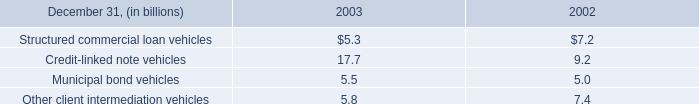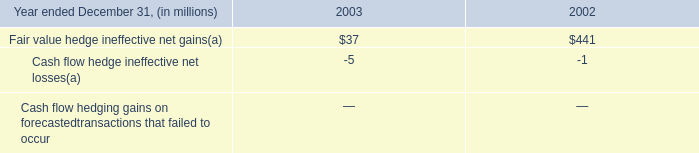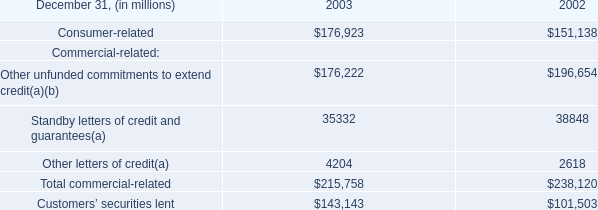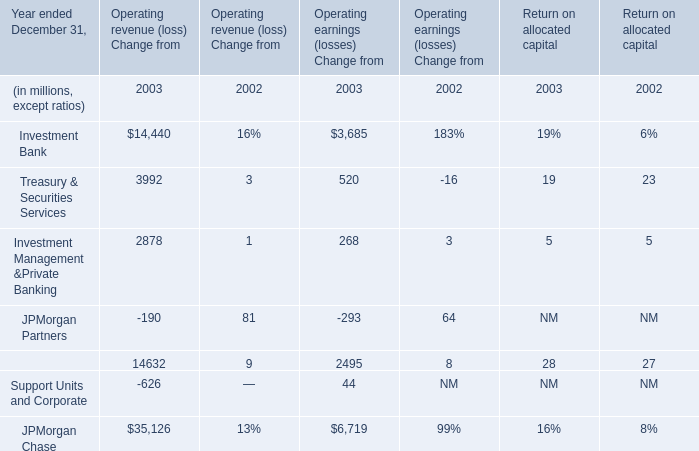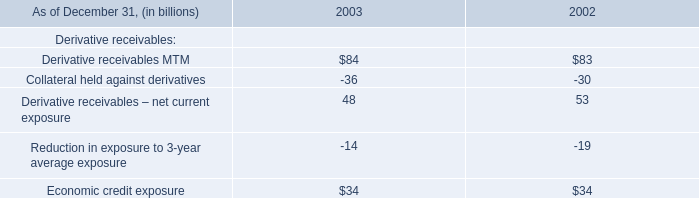What is the percentage of all Operating revenue (loss) Change that are positive to the total amount, in 2003? 
Computations: (((((14440 + 3992) + 2878) + 14632) + 35126) / ((((((14440 + 3992) + 2878) + 14632) + 35126) - 190) - 626))
Answer: 1.01162. 